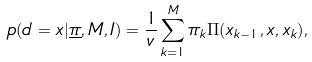<formula> <loc_0><loc_0><loc_500><loc_500>p ( d = x | \underline { \pi } , M , I ) = \frac { 1 } { v } \sum _ { k = 1 } ^ { M } { \pi _ { k } \Pi ( x _ { k - 1 } , x , x _ { k } ) } ,</formula> 